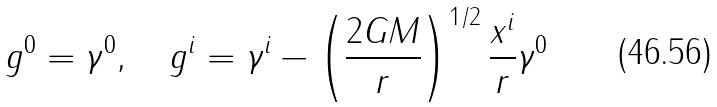<formula> <loc_0><loc_0><loc_500><loc_500>g ^ { 0 } = \gamma ^ { 0 } , \quad g ^ { i } = \gamma ^ { i } - \left ( \frac { 2 G M } { r } \right ) ^ { 1 / 2 } \frac { x ^ { i } } { r } \gamma ^ { 0 }</formula> 